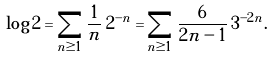<formula> <loc_0><loc_0><loc_500><loc_500>\log 2 = \sum _ { n \geq 1 } \frac { 1 } { n } \, 2 ^ { - n } = \sum _ { n \geq 1 } \frac { 6 } { 2 n - 1 } \, 3 ^ { - 2 n } .</formula> 